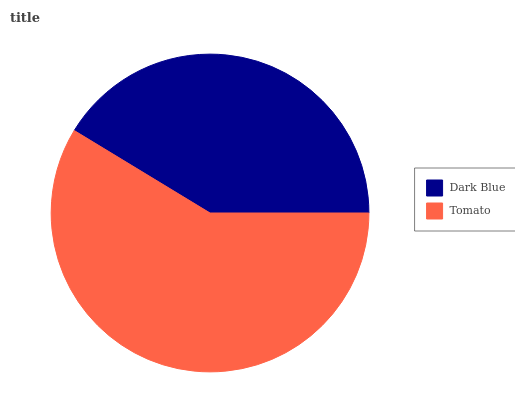Is Dark Blue the minimum?
Answer yes or no. Yes. Is Tomato the maximum?
Answer yes or no. Yes. Is Tomato the minimum?
Answer yes or no. No. Is Tomato greater than Dark Blue?
Answer yes or no. Yes. Is Dark Blue less than Tomato?
Answer yes or no. Yes. Is Dark Blue greater than Tomato?
Answer yes or no. No. Is Tomato less than Dark Blue?
Answer yes or no. No. Is Tomato the high median?
Answer yes or no. Yes. Is Dark Blue the low median?
Answer yes or no. Yes. Is Dark Blue the high median?
Answer yes or no. No. Is Tomato the low median?
Answer yes or no. No. 